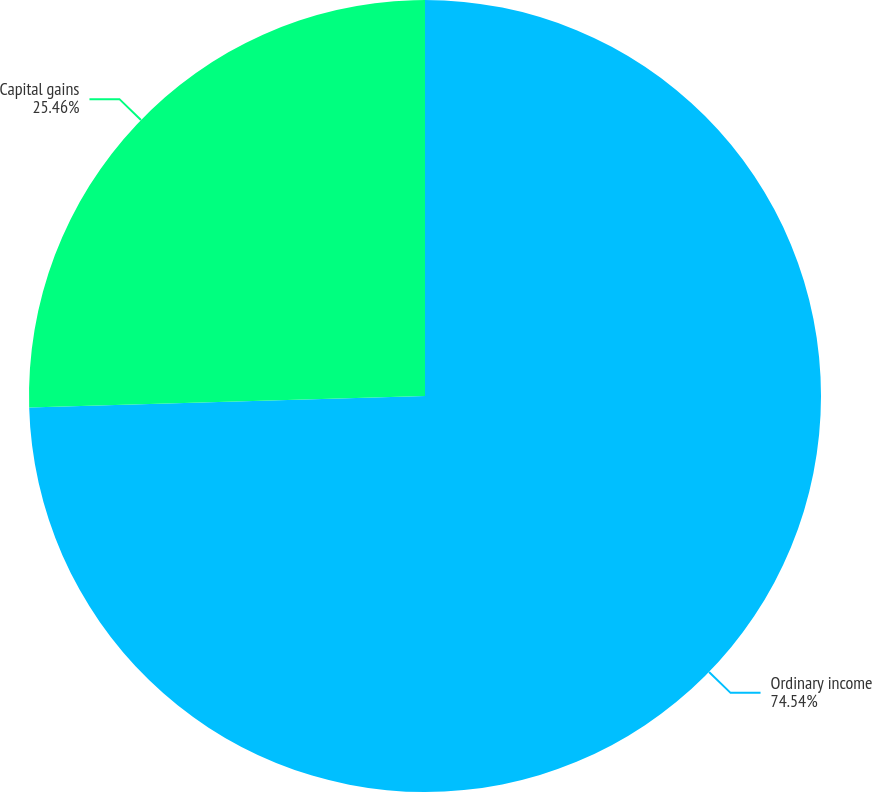Convert chart to OTSL. <chart><loc_0><loc_0><loc_500><loc_500><pie_chart><fcel>Ordinary income<fcel>Capital gains<nl><fcel>74.54%<fcel>25.46%<nl></chart> 